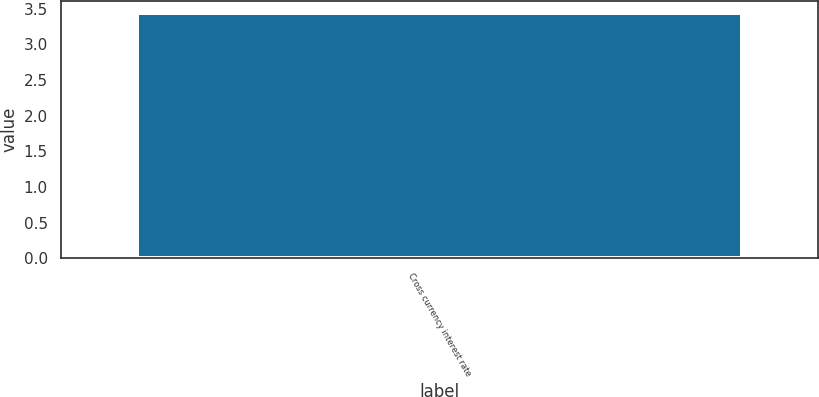<chart> <loc_0><loc_0><loc_500><loc_500><bar_chart><fcel>Cross currency interest rate<nl><fcel>3.44<nl></chart> 